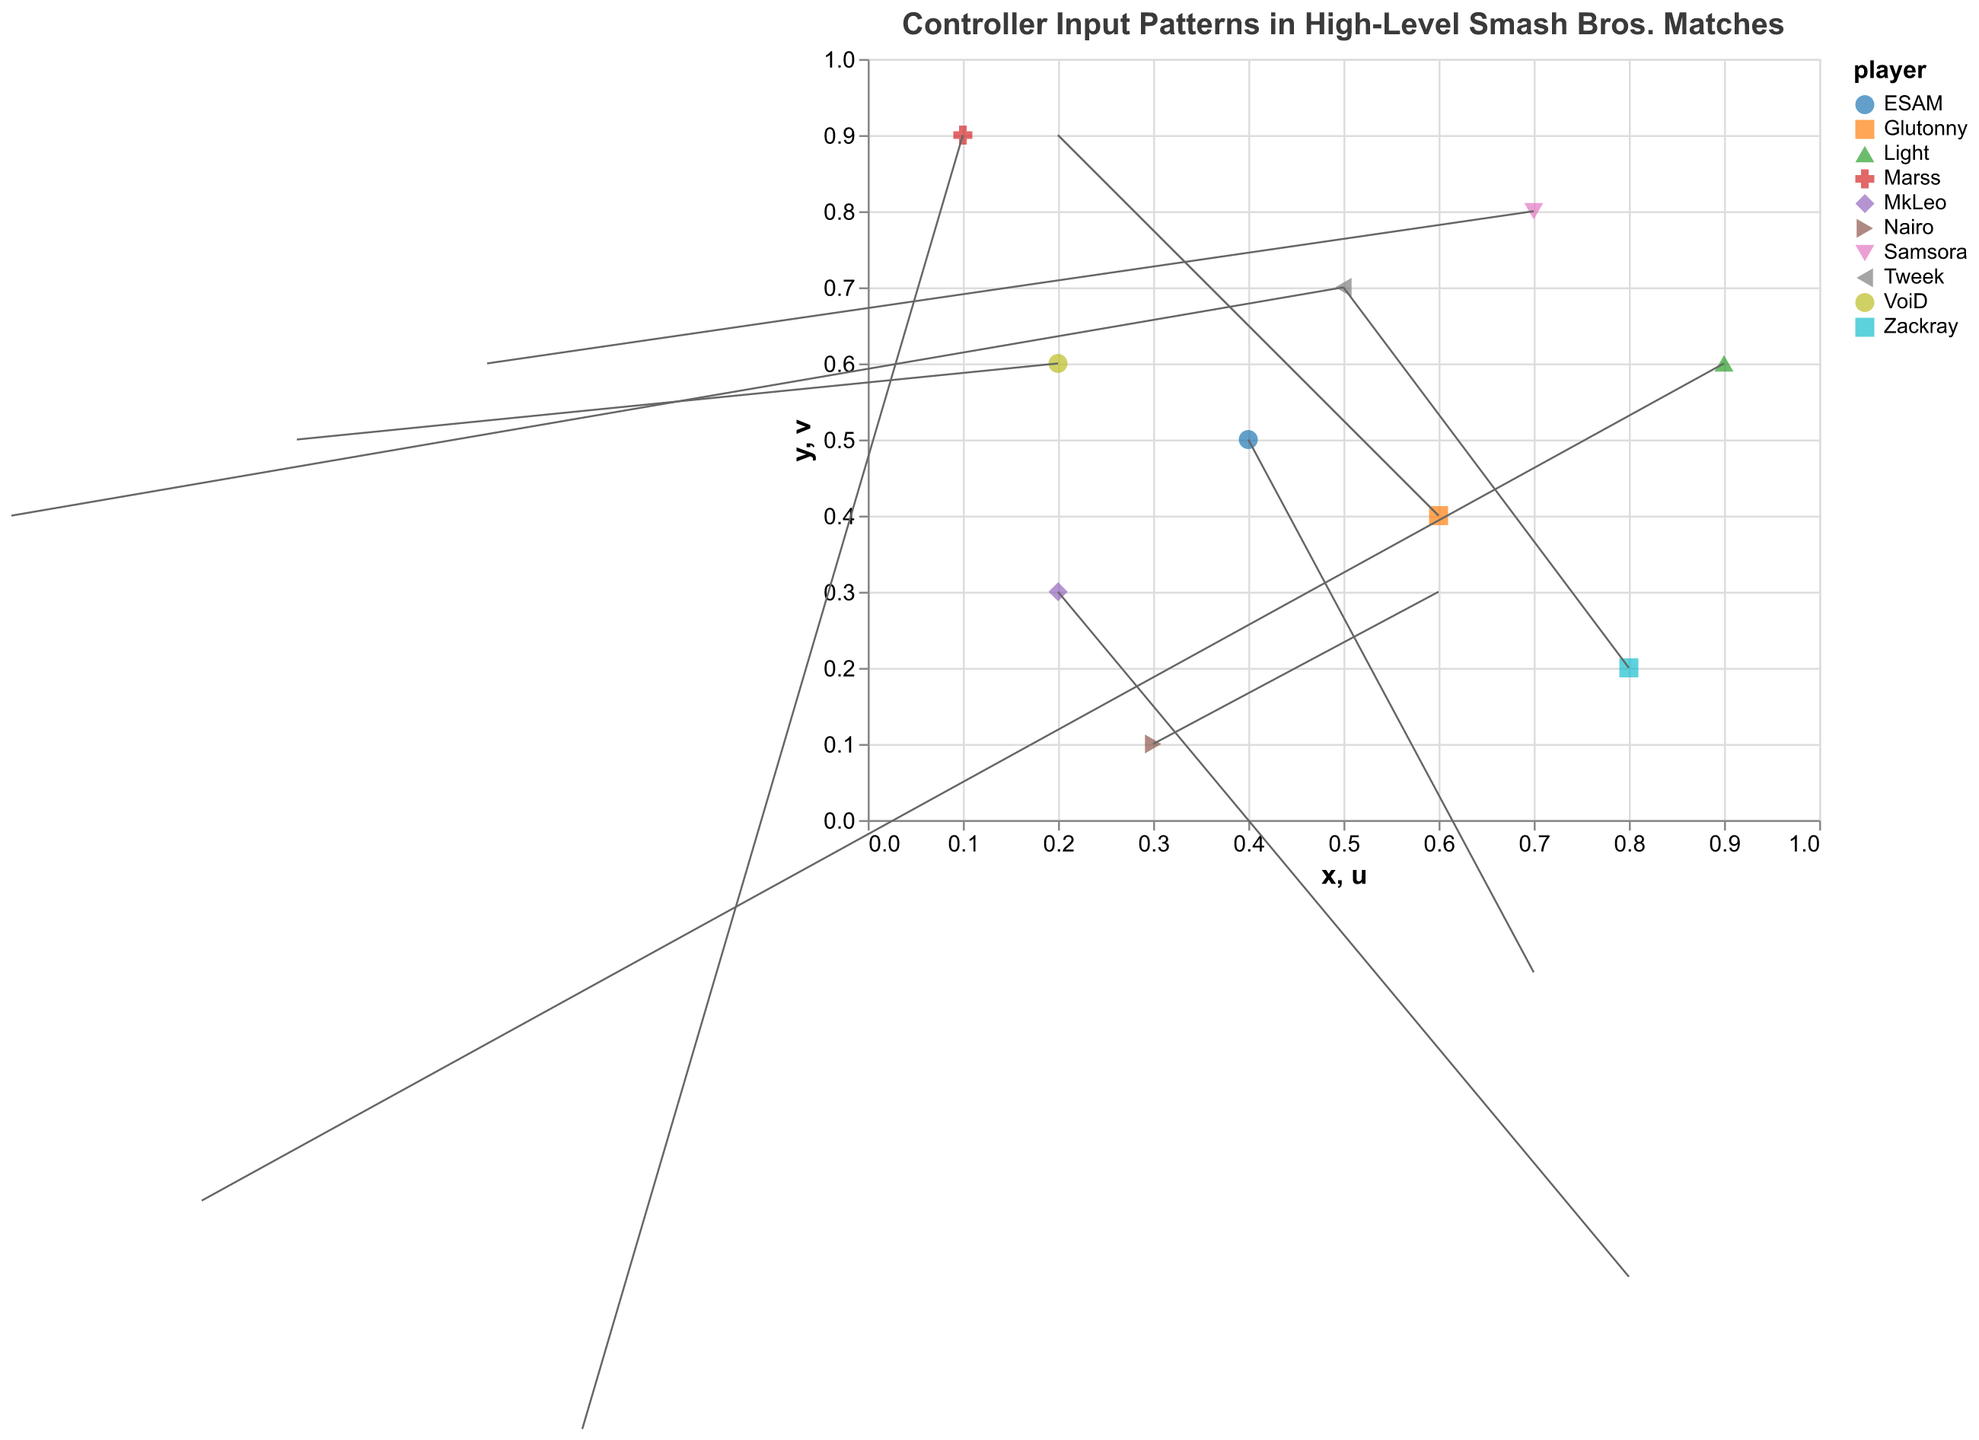What is the title of the figure? The title of the figure is displayed at the top and provides a summary of the visual content presented in the plot.
Answer: Controller Input Patterns in High-Level Smash Bros. Matches How many players are represented in the plot? Each player's data is represented by distinct colors and shapes, and there is a legend that indicates which players are included. By counting the unique entries in the legend, we get the total number of players.
Answer: 10 For which player is the action "Dash attack"? By looking at the tooltip information provided in the plot, you can hover over the data points to see which player corresponds to which action.
Answer: MkLeo What is the color used for the player Tweek? The plot uses a color scheme to differentiate players. To find Tweek's color, refer to the legend which maps player names to colors.
Answer: (This will depend on the color scheme used, e.g., blue) Which action has the largest horizontal movement (u value) and which player performed it? To find this, examine the 'u' values of each data point. The largest value of 'u' indicates the action and player with the most significant horizontal movement.
Answer: Dash attack, MkLeo What is the combined total of the vertical movements (v values) for players MkLeo and Marss? Add the 'v' values for MkLeo and Marss. MkLeo has a v of -0.6, and Marss has a v of -0.8. The combined total is -0.6 + (-0.8) = -1.4
Answer: -1.4 Which player and corresponding action have the most significant vertical movement upward? The most significant vertical movement upward can be determined by the highest positive 'v' value. Review the data points for the largest 'v' coordinate.
Answer: Glutonny, Forward smash Compare the horizontal movements of the players Light and VoiD. Who has a larger movement and in which direction? Compare the 'u' values of Light (-0.7) and VoiD (-0.6). Since both have negative values, the one with a larger absolute value indicates greater movement.
Answer: Light, left What is the average horizontal (u) value of all the data points? To calculate the average horizontal movement, sum all 'u' values and divide by the number of data points (10). The sum of 'u' values is 0.8 + (-0.9) + 0.5 + (-0.3) + 0.2 + (-0.7) + 0.6 + (-0.4) + 0.7 + (-0.6) = -0.1. The average is -0.1/10 = -0.01.
Answer: -0.01 Between Nairo's "Neutral air" and Samsora's "Grab", which action moves vertically more and by how much? Compare the 'v' values of Nairo (0.3) and Samsora (0.6). Samsora moves more vertically by 0.6 - 0.3 = 0.3.
Answer: Samsora, by 0.3 